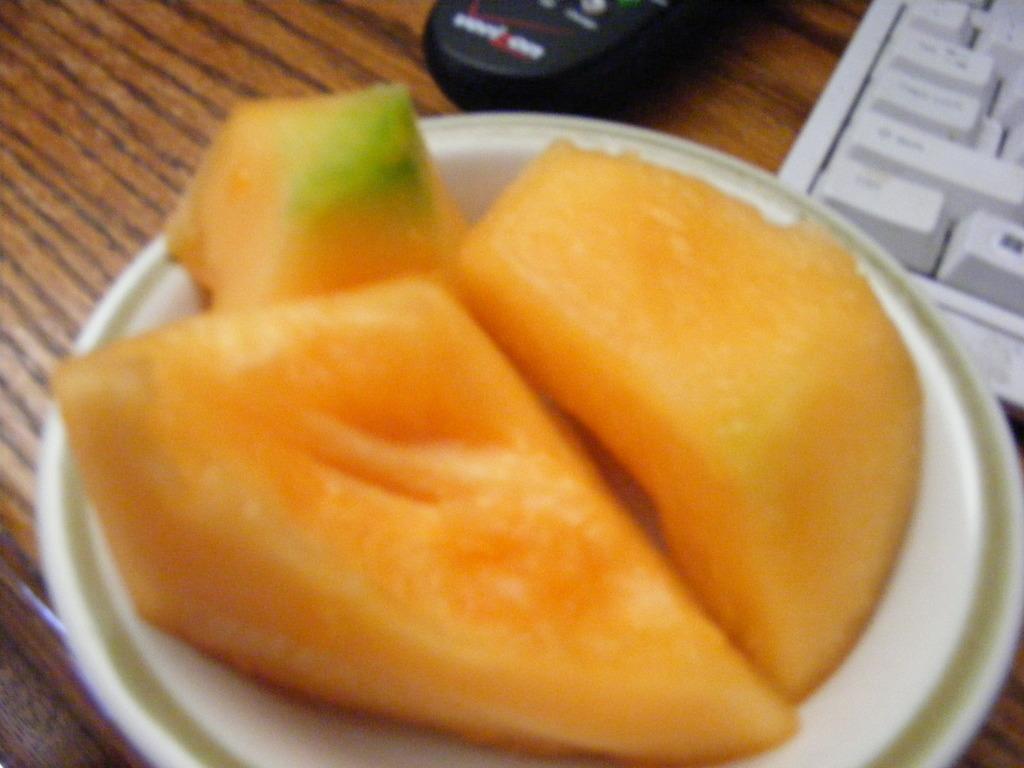Describe this image in one or two sentences. In the image we can see a wooden surface, on it we can see a gadget, keyboard and plate. In the plate there are pieces of fruit.  